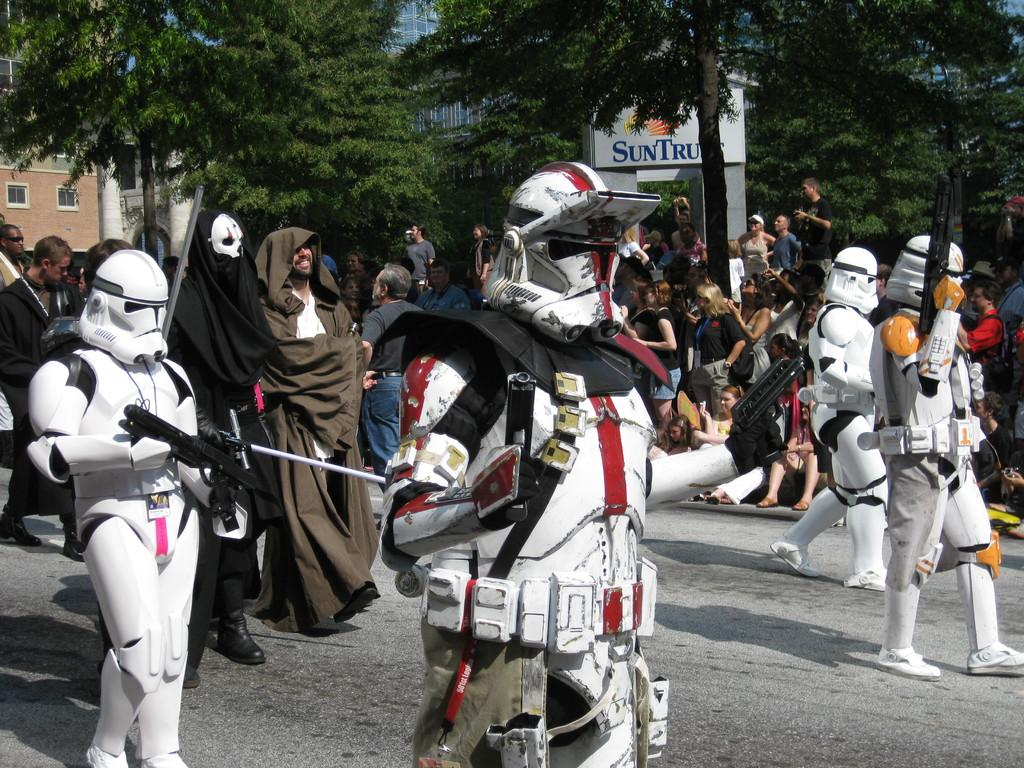What is happening in the image involving the people? Most of the people are celebrating Star Wars. How are the people dressed in the image? Most of the people are wearing Star Wars costumes. What type of magic is being performed by the people in the image? There is no magic being performed in the image; the people are celebrating Star Wars and wearing costumes. 